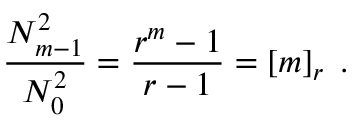<formula> <loc_0><loc_0><loc_500><loc_500>\frac { N _ { m - 1 } ^ { 2 } } { N _ { 0 } ^ { 2 } } = \frac { r ^ { m } - 1 } { r - 1 } = \left [ m \right ] _ { r } \, .</formula> 